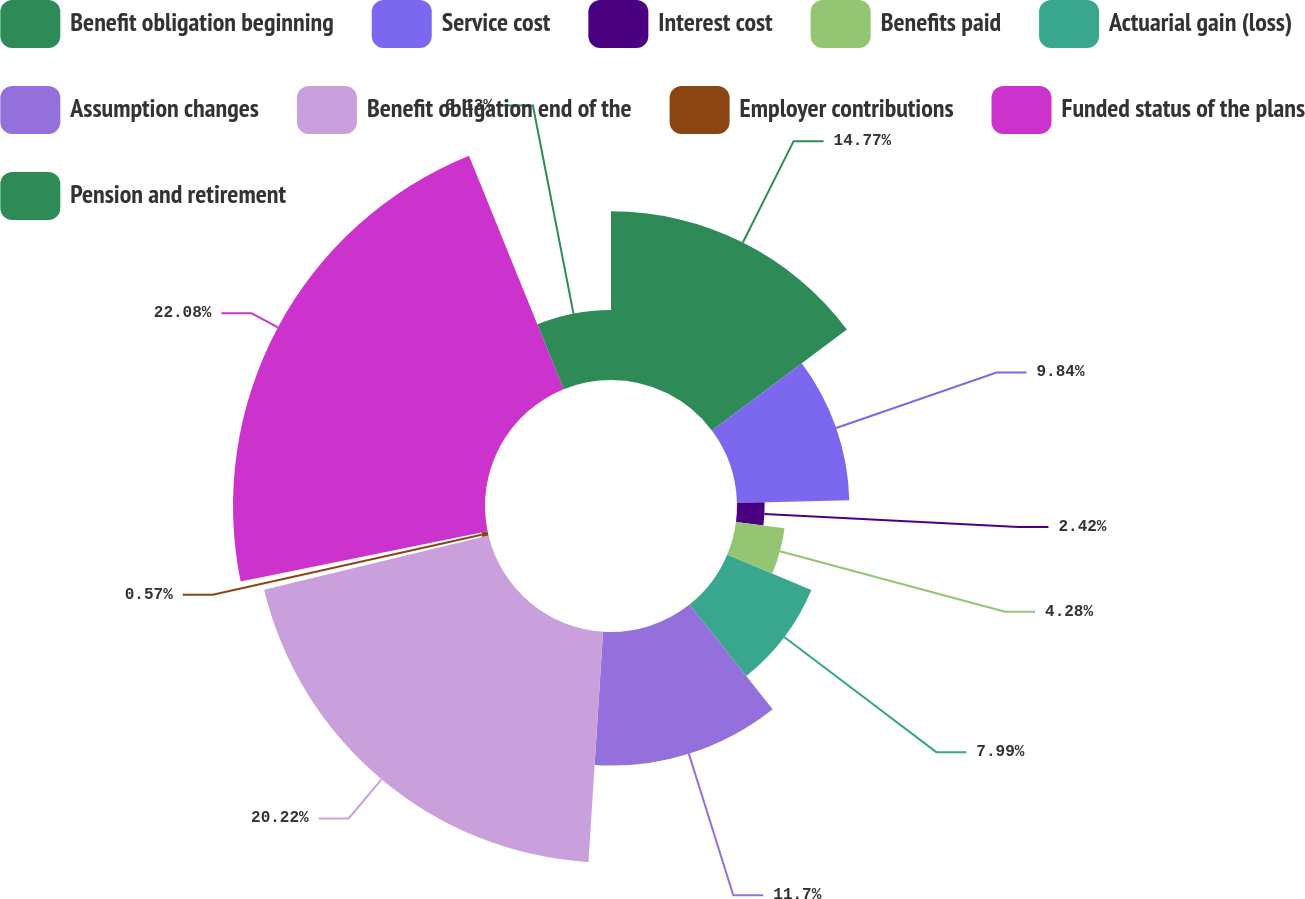Convert chart. <chart><loc_0><loc_0><loc_500><loc_500><pie_chart><fcel>Benefit obligation beginning<fcel>Service cost<fcel>Interest cost<fcel>Benefits paid<fcel>Actuarial gain (loss)<fcel>Assumption changes<fcel>Benefit obligation end of the<fcel>Employer contributions<fcel>Funded status of the plans<fcel>Pension and retirement<nl><fcel>14.77%<fcel>9.84%<fcel>2.42%<fcel>4.28%<fcel>7.99%<fcel>11.7%<fcel>20.22%<fcel>0.57%<fcel>22.07%<fcel>6.13%<nl></chart> 